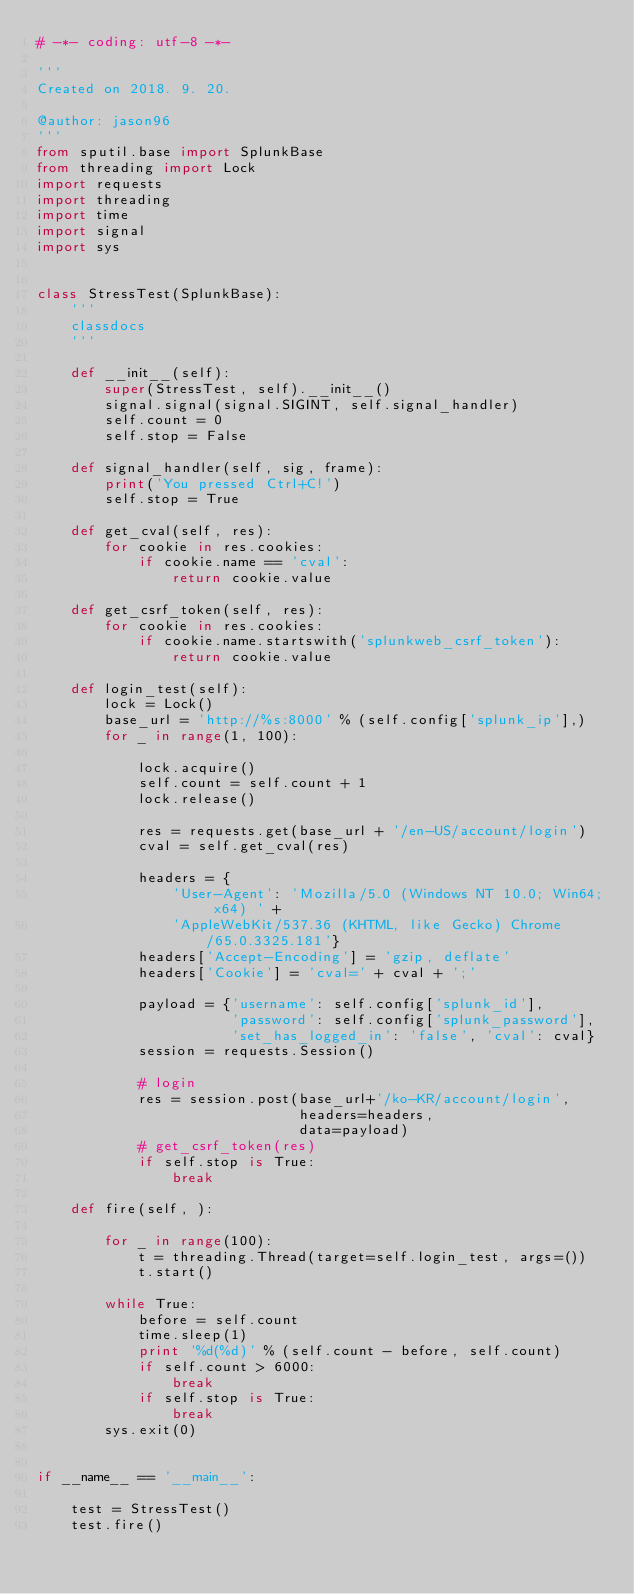<code> <loc_0><loc_0><loc_500><loc_500><_Python_># -*- coding: utf-8 -*-

'''
Created on 2018. 9. 20.

@author: jason96
'''
from sputil.base import SplunkBase
from threading import Lock
import requests
import threading
import time
import signal
import sys


class StressTest(SplunkBase):
    '''
    classdocs
    '''

    def __init__(self):
        super(StressTest, self).__init__()
        signal.signal(signal.SIGINT, self.signal_handler)
        self.count = 0
        self.stop = False

    def signal_handler(self, sig, frame):
        print('You pressed Ctrl+C!')
        self.stop = True

    def get_cval(self, res):
        for cookie in res.cookies:
            if cookie.name == 'cval':
                return cookie.value

    def get_csrf_token(self, res):
        for cookie in res.cookies:
            if cookie.name.startswith('splunkweb_csrf_token'):
                return cookie.value

    def login_test(self):
        lock = Lock()
        base_url = 'http://%s:8000' % (self.config['splunk_ip'],)
        for _ in range(1, 100):

            lock.acquire()
            self.count = self.count + 1
            lock.release()

            res = requests.get(base_url + '/en-US/account/login')
            cval = self.get_cval(res)

            headers = {
                'User-Agent': 'Mozilla/5.0 (Windows NT 10.0; Win64; x64) ' +
                'AppleWebKit/537.36 (KHTML, like Gecko) Chrome/65.0.3325.181'}
            headers['Accept-Encoding'] = 'gzip, deflate'
            headers['Cookie'] = 'cval=' + cval + ';'

            payload = {'username': self.config['splunk_id'],
                       'password': self.config['splunk_password'],
                       'set_has_logged_in': 'false', 'cval': cval}
            session = requests.Session()

            # login
            res = session.post(base_url+'/ko-KR/account/login',
                               headers=headers,
                               data=payload)
            # get_csrf_token(res)
            if self.stop is True:
                break

    def fire(self, ):

        for _ in range(100):
            t = threading.Thread(target=self.login_test, args=())
            t.start()

        while True:
            before = self.count
            time.sleep(1)
            print '%d(%d)' % (self.count - before, self.count)
            if self.count > 6000:
                break
            if self.stop is True:
                break
        sys.exit(0)


if __name__ == '__main__':

    test = StressTest()
    test.fire()
</code> 